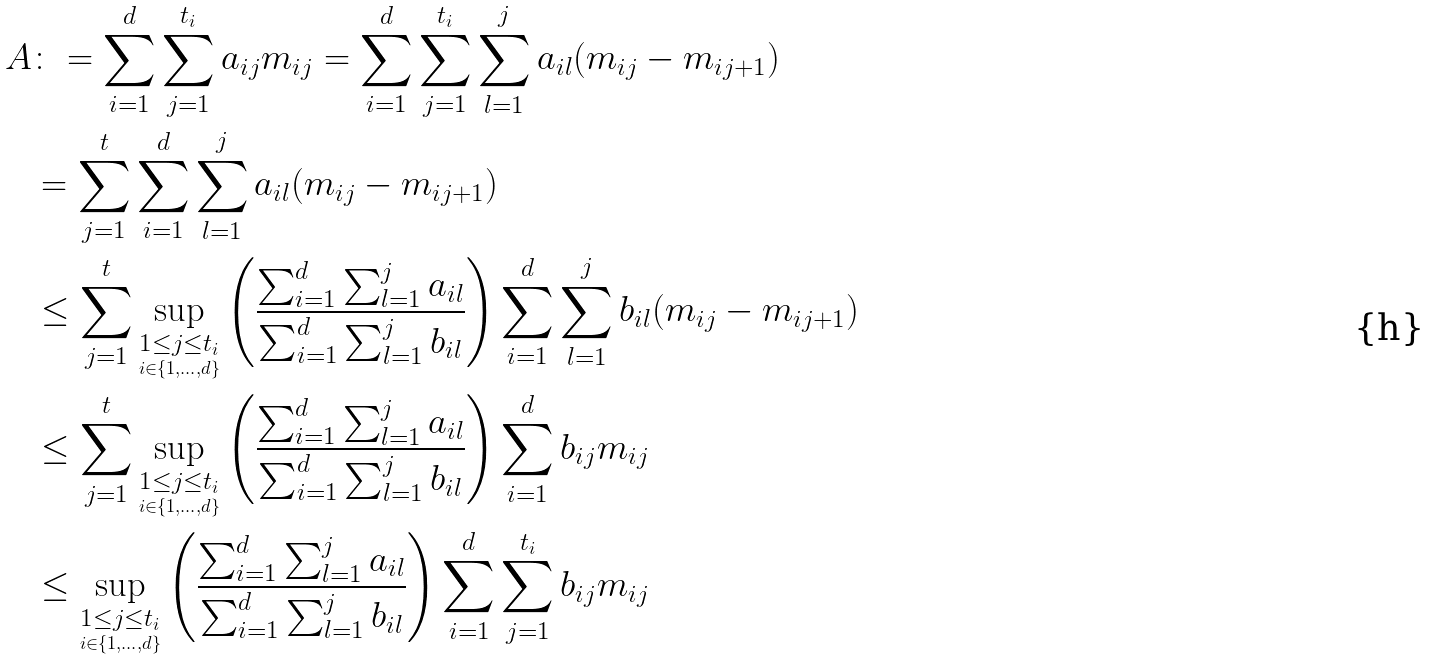Convert formula to latex. <formula><loc_0><loc_0><loc_500><loc_500>A & \colon = \sum _ { i = 1 } ^ { d } \sum _ { j = 1 } ^ { t _ { i } } a _ { i j } m _ { i j } = \sum _ { i = 1 } ^ { d } \sum _ { j = 1 } ^ { t _ { i } } \sum _ { l = 1 } ^ { j } a _ { i l } ( m _ { i j } - m _ { i j + 1 } ) \\ & = \sum _ { j = 1 } ^ { t } \sum _ { i = 1 } ^ { d } \sum _ { l = 1 } ^ { j } a _ { i l } ( m _ { i j } - m _ { i j + 1 } ) \\ & \leq \sum _ { j = 1 } ^ { t } \sup _ { \underset { i \in \{ 1 , \dots , d \} } { 1 \leq j \leq t _ { i } } } \left ( \frac { \sum _ { i = 1 } ^ { d } \sum _ { l = 1 } ^ { j } a _ { i l } } { \sum _ { i = 1 } ^ { d } \sum _ { l = 1 } ^ { j } b _ { i l } } \right ) \sum _ { i = 1 } ^ { d } \sum _ { l = 1 } ^ { j } b _ { i l } ( m _ { i j } - m _ { i j + 1 } ) \\ & \leq \sum _ { j = 1 } ^ { t } \sup _ { \underset { i \in \{ 1 , \dots , d \} } { 1 \leq j \leq t _ { i } } } \left ( \frac { \sum _ { i = 1 } ^ { d } \sum _ { l = 1 } ^ { j } a _ { i l } } { \sum _ { i = 1 } ^ { d } \sum _ { l = 1 } ^ { j } b _ { i l } } \right ) \sum _ { i = 1 } ^ { d } b _ { i j } m _ { i j } \\ & \leq \sup _ { \underset { i \in \{ 1 , \dots , d \} } { 1 \leq j \leq t _ { i } } } \left ( \frac { \sum _ { i = 1 } ^ { d } \sum _ { l = 1 } ^ { j } a _ { i l } } { \sum _ { i = 1 } ^ { d } \sum _ { l = 1 } ^ { j } b _ { i l } } \right ) \sum _ { i = 1 } ^ { d } \sum _ { j = 1 } ^ { t _ { i } } b _ { i j } m _ { i j }</formula> 